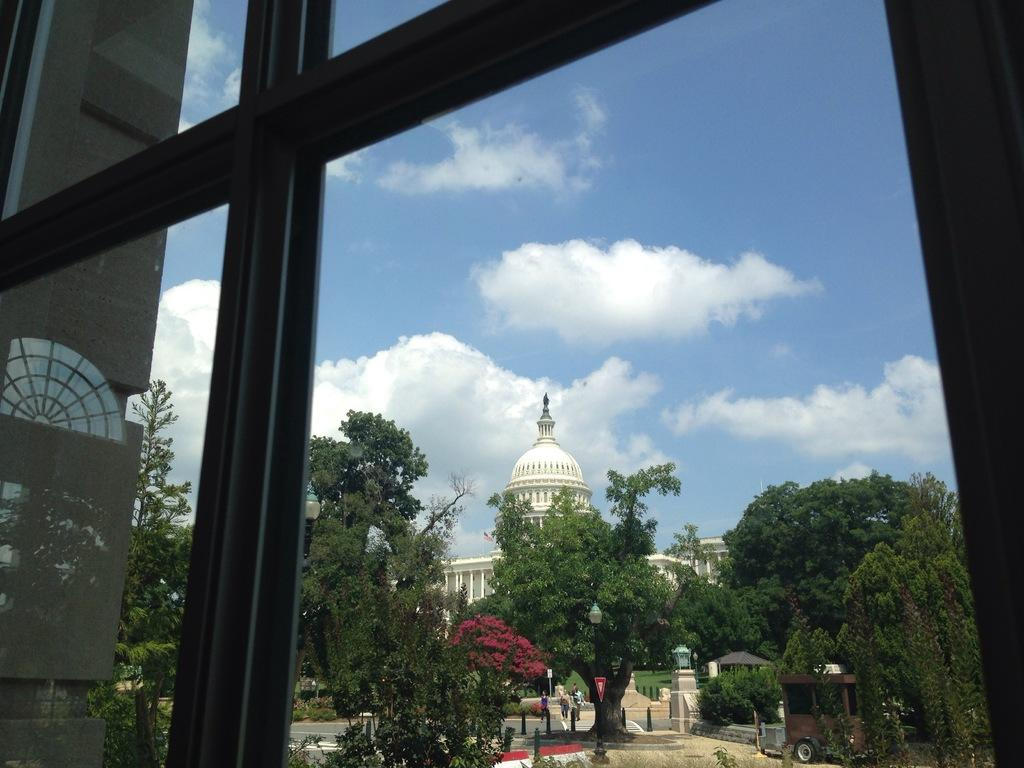What type of structure is visible through the glass window in the image? The glass window allows a view of a building. What else can be seen through the window besides the building? Trees and the sky are visible through the window. What is the condition of the sky in the image? Clouds are present in the sky, which is visible through the window. What type of board is being used to hammer nails into the sofa in the image? There is no board or sofa present in the image; it features a glass window with a view of a building, trees, and the sky. 